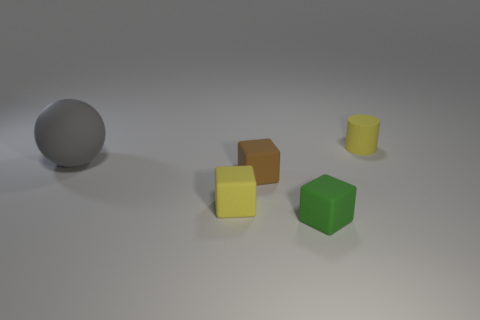Add 1 cylinders. How many objects exist? 6 Subtract all cylinders. How many objects are left? 4 Add 2 tiny matte objects. How many tiny matte objects exist? 6 Subtract 0 gray cubes. How many objects are left? 5 Subtract all tiny metal things. Subtract all brown cubes. How many objects are left? 4 Add 2 yellow rubber cubes. How many yellow rubber cubes are left? 3 